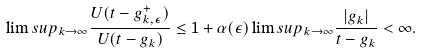Convert formula to latex. <formula><loc_0><loc_0><loc_500><loc_500>\lim s u p _ { k \rightarrow \infty } \frac { U ( t - g _ { k , \epsilon } ^ { + } ) } { U ( t - g _ { k } ) } \leq 1 + \alpha ( \epsilon ) \lim s u p _ { k \rightarrow \infty } \frac { | g _ { k } | } { t - g _ { k } } < \infty .</formula> 